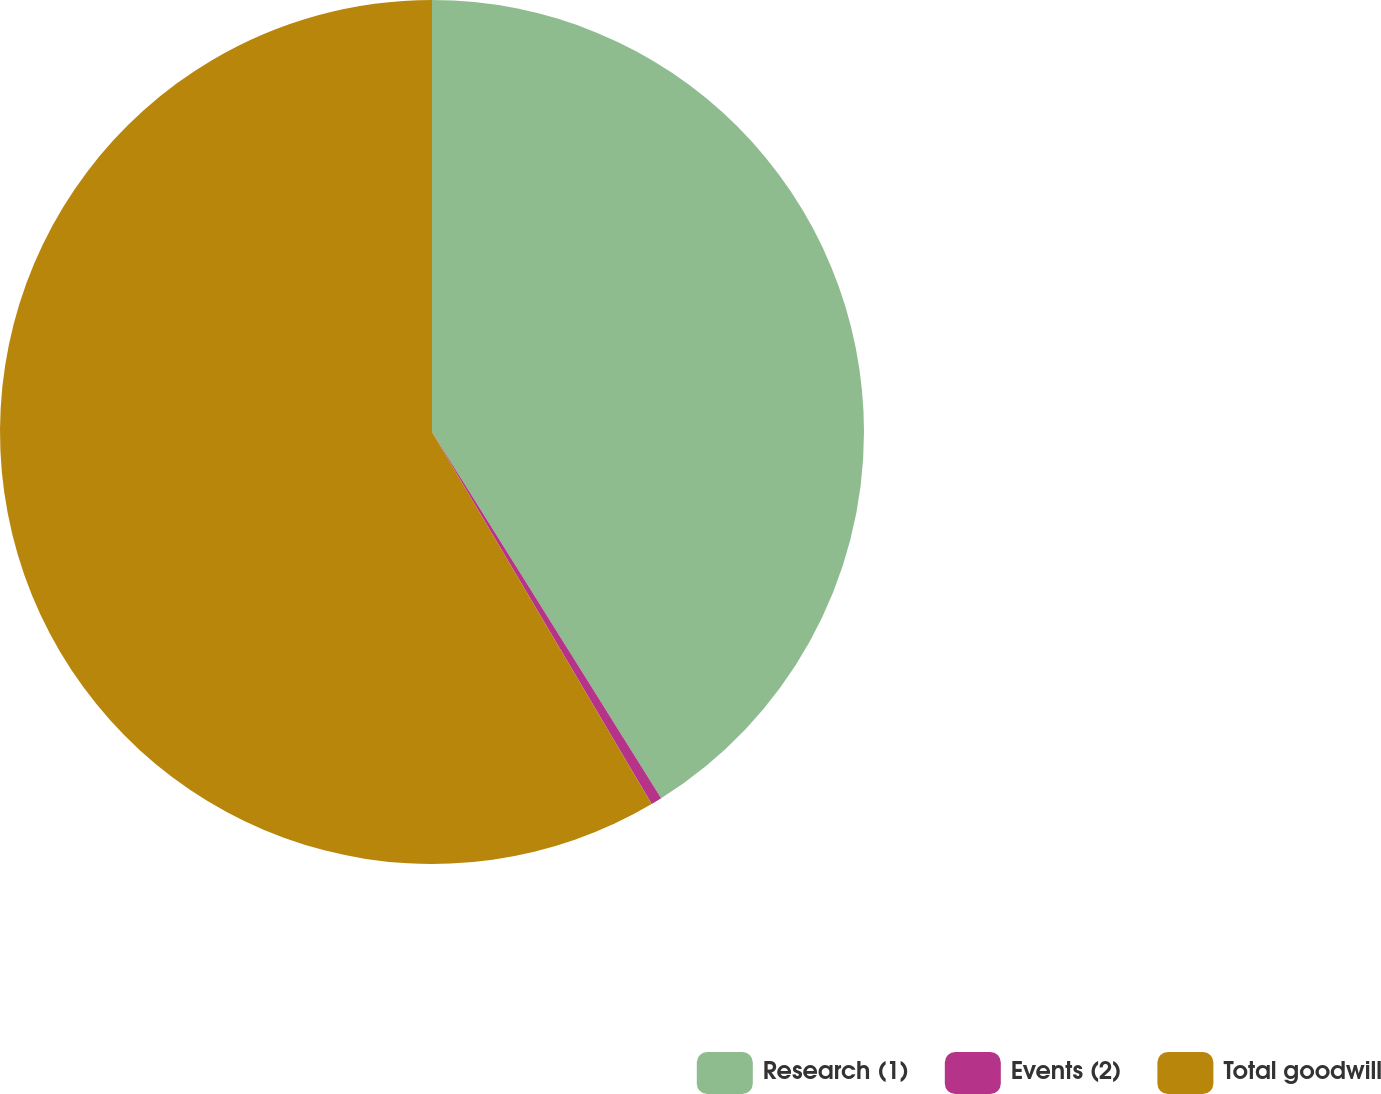<chart> <loc_0><loc_0><loc_500><loc_500><pie_chart><fcel>Research (1)<fcel>Events (2)<fcel>Total goodwill<nl><fcel>41.1%<fcel>0.41%<fcel>58.49%<nl></chart> 